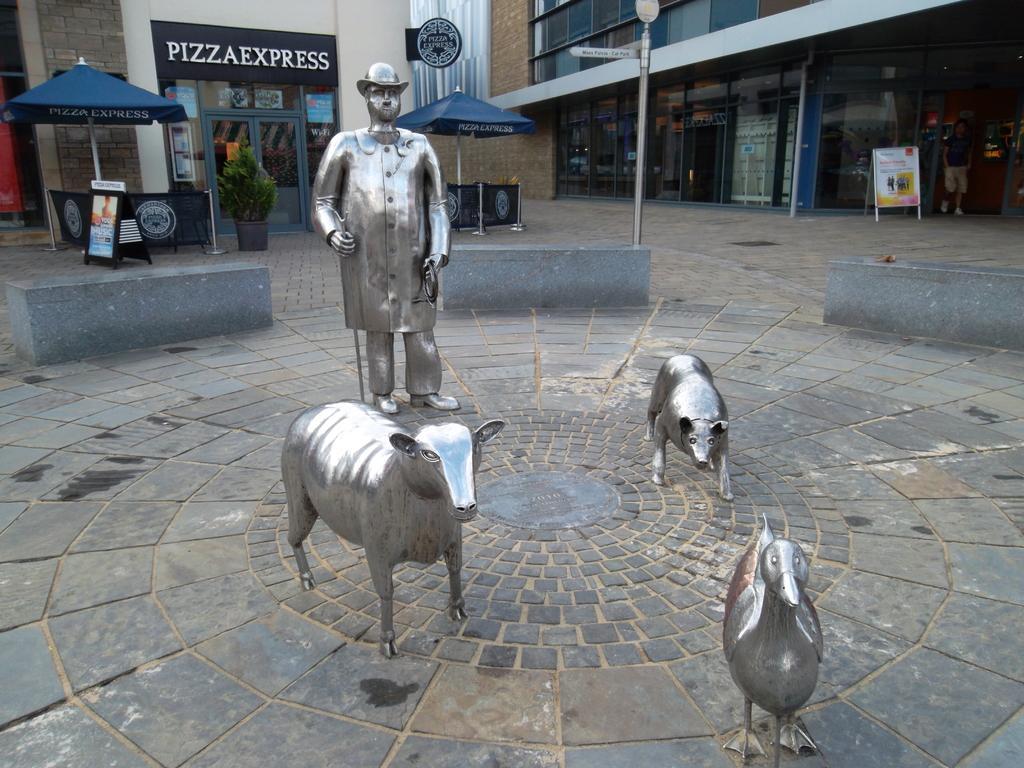In one or two sentences, can you explain what this image depicts? In this picture we can see a statue of person,statue animals on the ground and in the background we can see buildings. 